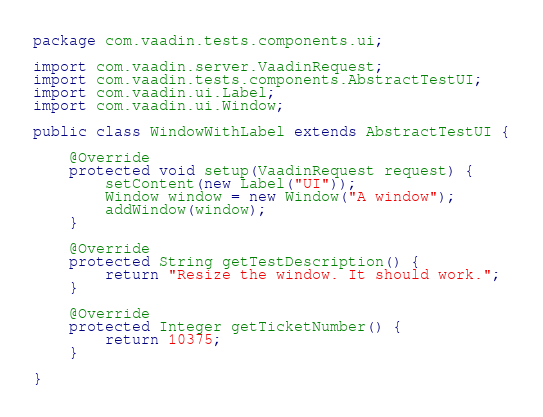Convert code to text. <code><loc_0><loc_0><loc_500><loc_500><_Java_>package com.vaadin.tests.components.ui;

import com.vaadin.server.VaadinRequest;
import com.vaadin.tests.components.AbstractTestUI;
import com.vaadin.ui.Label;
import com.vaadin.ui.Window;

public class WindowWithLabel extends AbstractTestUI {

    @Override
    protected void setup(VaadinRequest request) {
        setContent(new Label("UI"));
        Window window = new Window("A window");
        addWindow(window);
    }

    @Override
    protected String getTestDescription() {
        return "Resize the window. It should work.";
    }

    @Override
    protected Integer getTicketNumber() {
        return 10375;
    }

}
</code> 